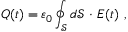Convert formula to latex. <formula><loc_0><loc_0><loc_500><loc_500>Q ( t ) = \varepsilon _ { 0 } \oint _ { \mathcal { S } } d \mathcal { S } \ { \cdot } \ { E } ( t ) \ ,</formula> 